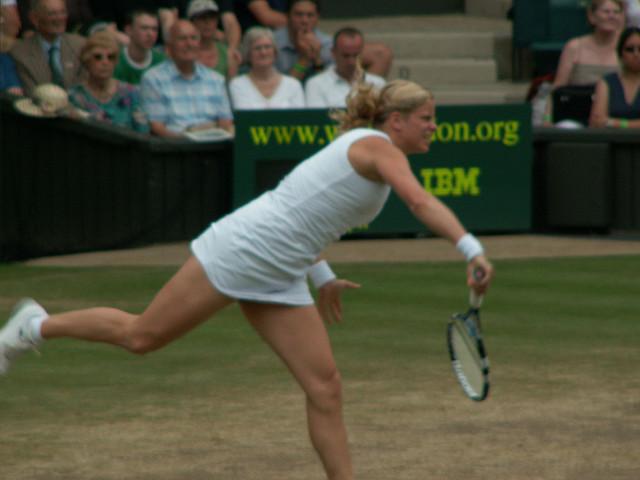What is on the lady's wrists?
Short answer required. Wristbands. Where is the person at?
Quick response, please. Tennis court. Does she have a bandage around her thigh?
Give a very brief answer. No. What word is clear in the background?
Concise answer only. Ibm. What color is her shirt?
Answer briefly. White. Do the people watching look excited?
Be succinct. No. What is the complete URL from the banner in the background?
Be succinct. Wwwwimbledonorg. What type of hairstyle is this person's hair in?
Give a very brief answer. Ponytail. What is on the players head?
Give a very brief answer. Hair. 